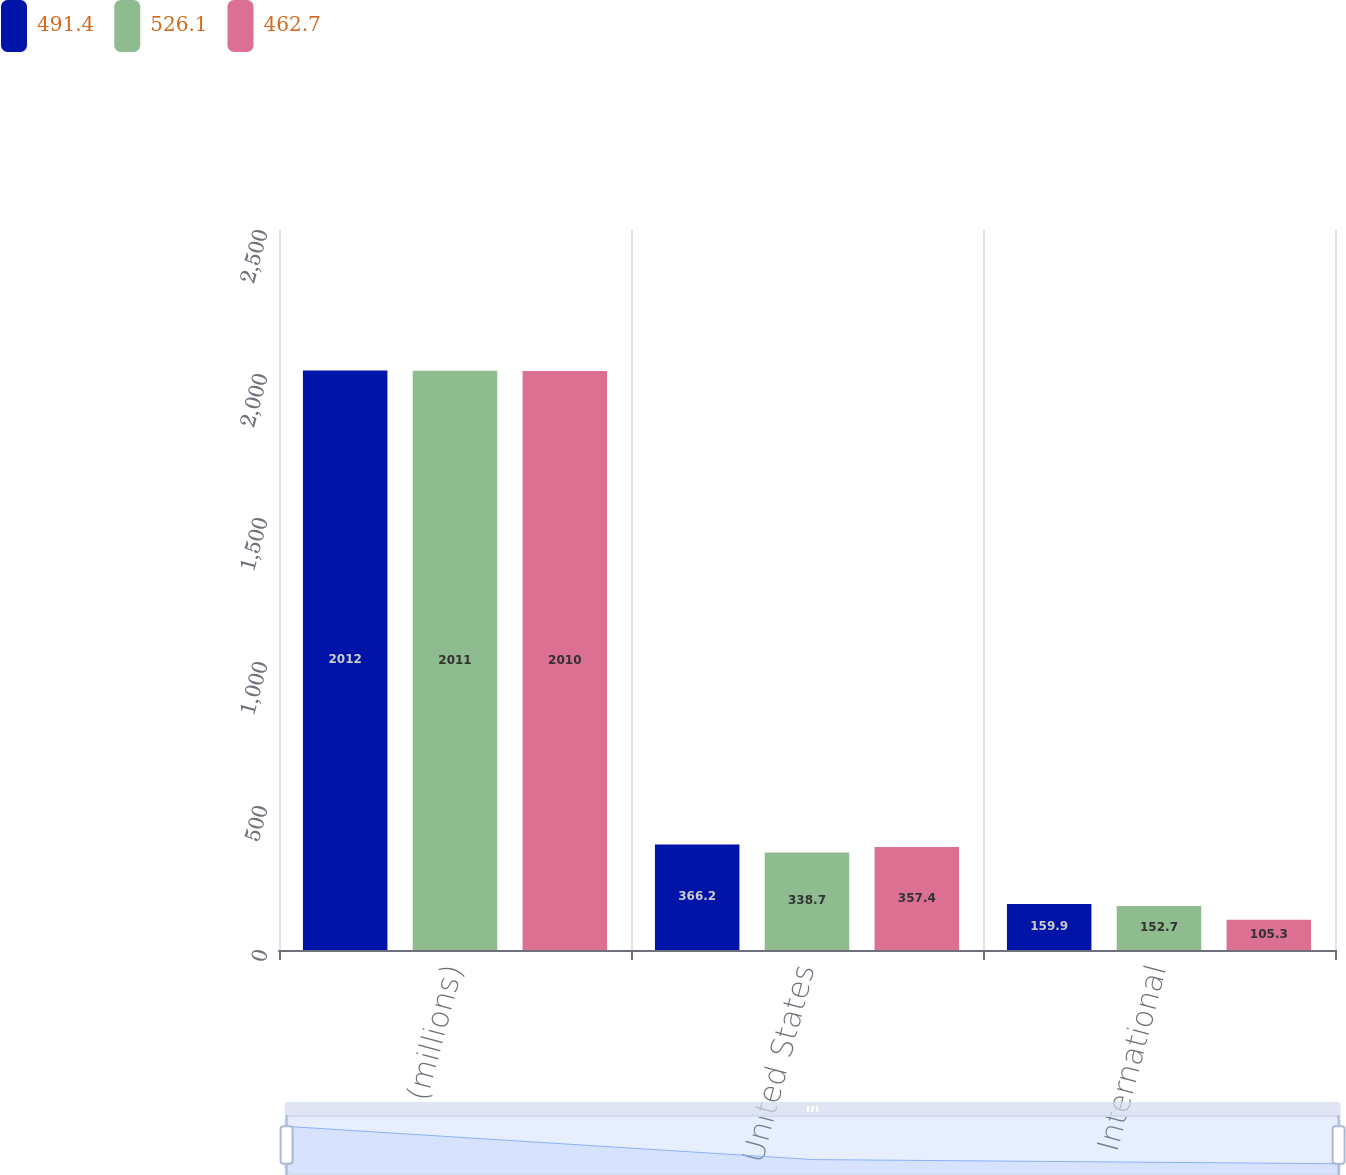Convert chart. <chart><loc_0><loc_0><loc_500><loc_500><stacked_bar_chart><ecel><fcel>(millions)<fcel>United States<fcel>International<nl><fcel>491.4<fcel>2012<fcel>366.2<fcel>159.9<nl><fcel>526.1<fcel>2011<fcel>338.7<fcel>152.7<nl><fcel>462.7<fcel>2010<fcel>357.4<fcel>105.3<nl></chart> 